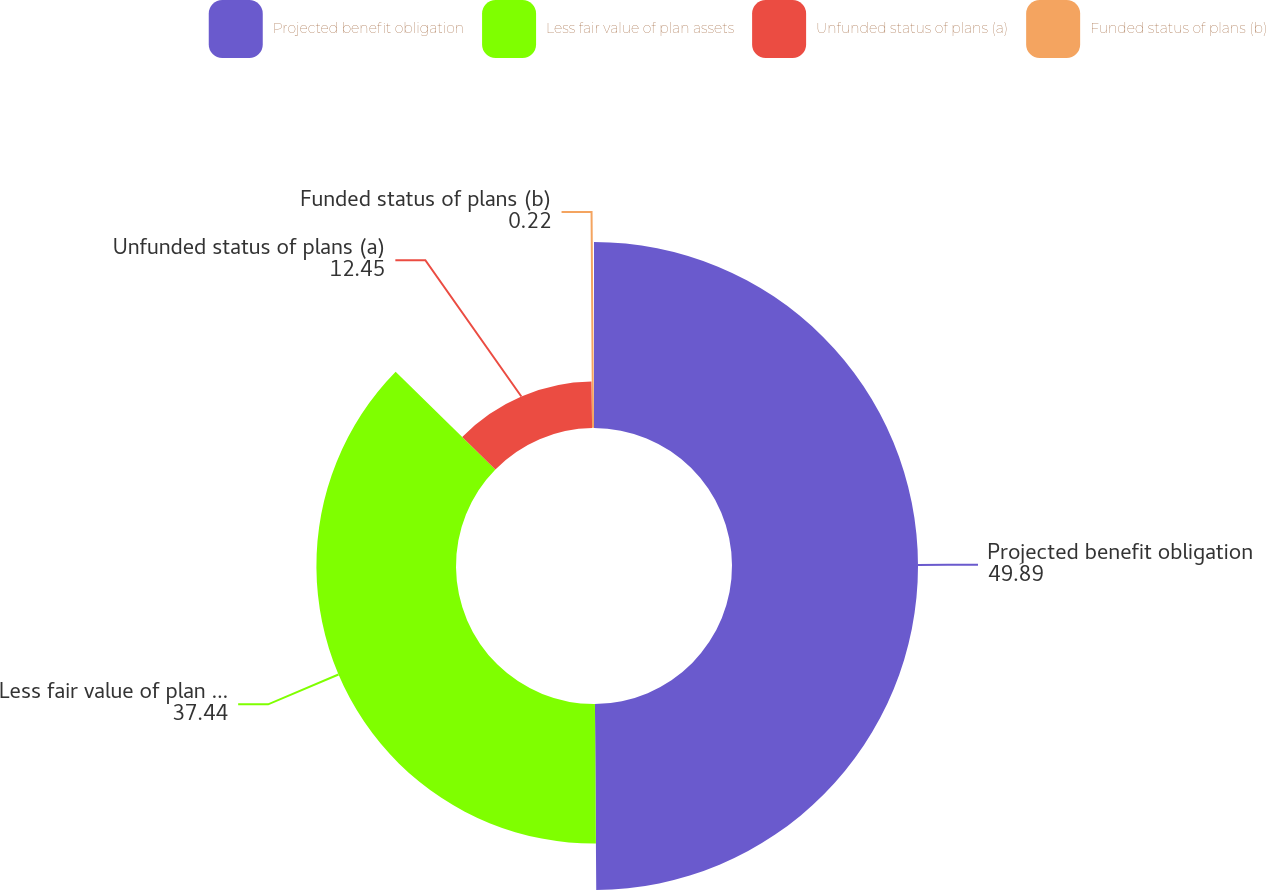Convert chart. <chart><loc_0><loc_0><loc_500><loc_500><pie_chart><fcel>Projected benefit obligation<fcel>Less fair value of plan assets<fcel>Unfunded status of plans (a)<fcel>Funded status of plans (b)<nl><fcel>49.89%<fcel>37.44%<fcel>12.45%<fcel>0.22%<nl></chart> 